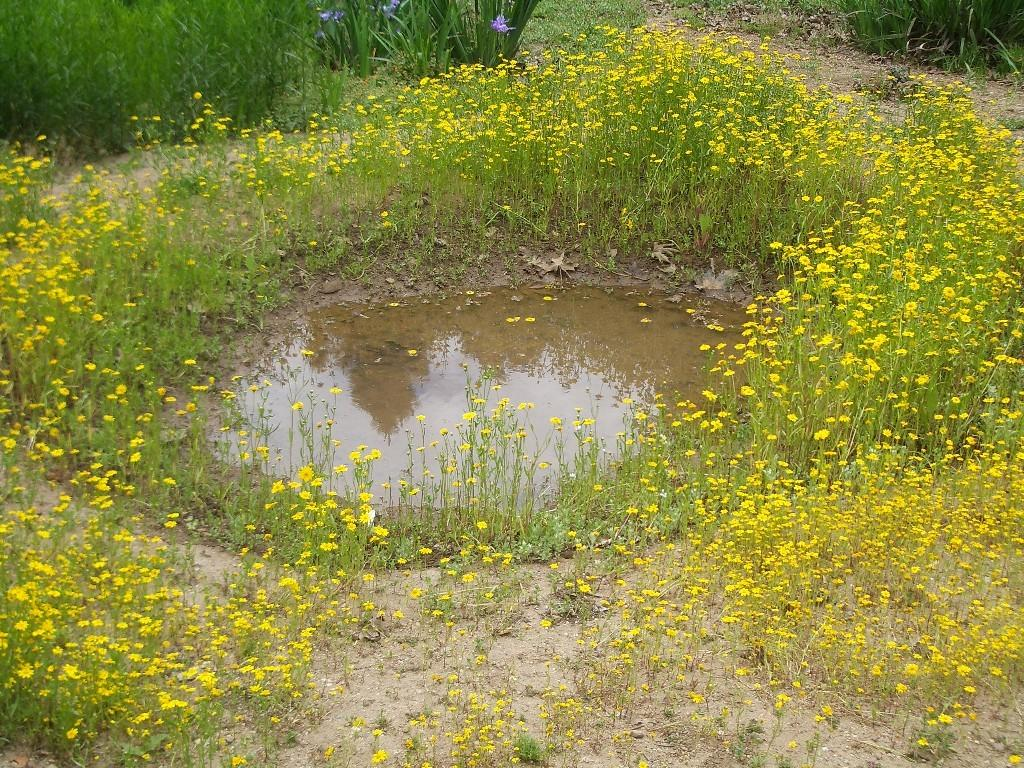What type of surface is visible in the image? There is ground visible in the image. What type of vegetation can be seen in the image? There are flowers and plants visible in the image. What natural element is present in the image? There is water visible in the image. What can be seen in the background of the image? There are plants in the background of the image. What type of pie is being served in the image? There is no pie present in the image. What type of view can be seen from the location in the image? The image does not provide enough information to determine the view from the location. 